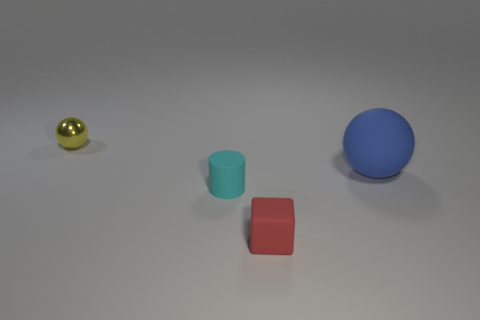What number of other objects are there of the same size as the red matte object?
Provide a short and direct response. 2. How many objects are cubes or large cyan metallic blocks?
Your answer should be very brief. 1. Is there any other thing that has the same color as the small ball?
Give a very brief answer. No. Are the yellow ball and the cylinder that is behind the red matte thing made of the same material?
Your answer should be compact. No. What shape is the tiny object that is behind the sphere on the right side of the cyan thing?
Offer a terse response. Sphere. What is the shape of the thing that is both on the left side of the red cube and in front of the tiny metal ball?
Make the answer very short. Cylinder. How many things are either matte balls or tiny objects in front of the blue matte sphere?
Your answer should be compact. 3. What is the material of the tiny yellow object that is the same shape as the blue rubber object?
Give a very brief answer. Metal. Is there any other thing that has the same material as the yellow ball?
Provide a short and direct response. No. There is a thing that is both to the right of the cyan matte object and to the left of the big ball; what is its material?
Offer a very short reply. Rubber. 